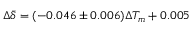<formula> <loc_0><loc_0><loc_500><loc_500>\Delta \bar { \delta } = ( - 0 . 0 4 6 \pm 0 . 0 0 6 ) \Delta T _ { m } + 0 . 0 0 5</formula> 